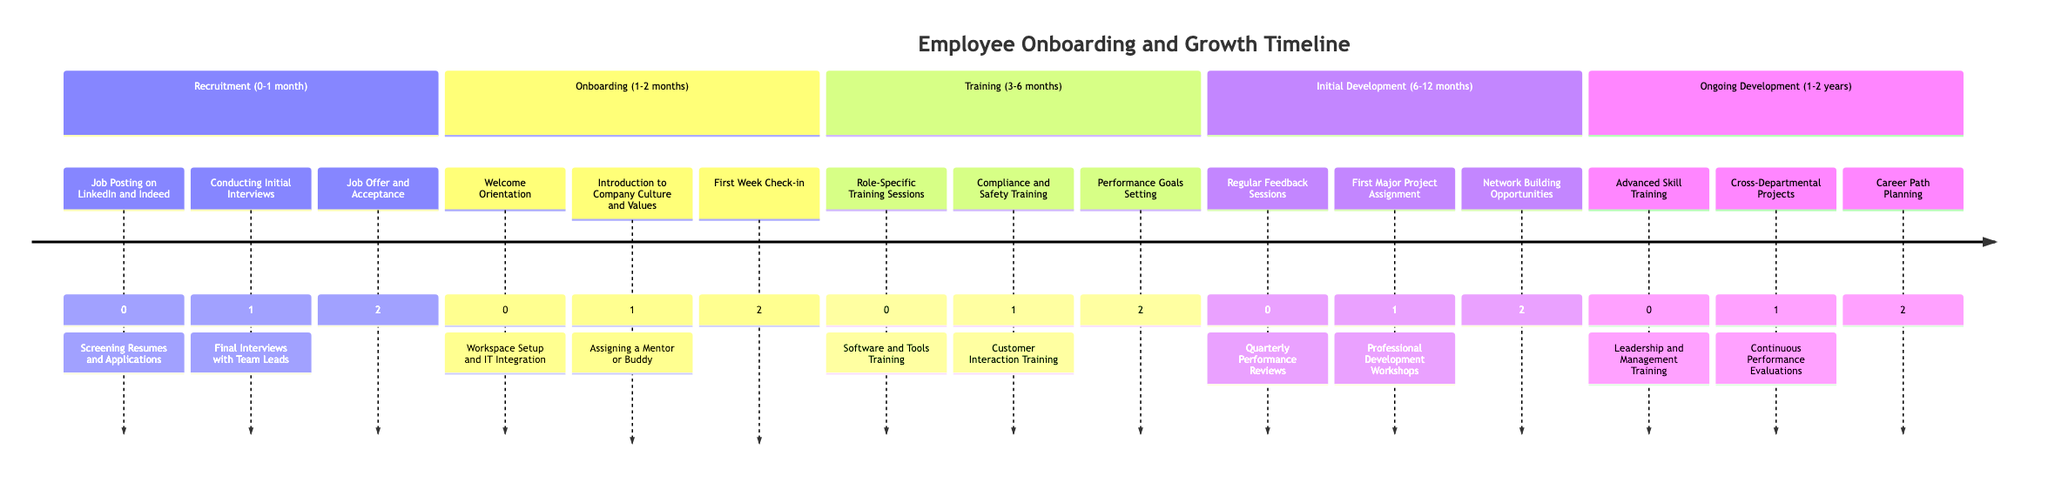What is the duration of the Onboarding phase? The Onboarding phase lasts from 1 to 2 months according to the timeline, which clearly states the range for that phase.
Answer: 1-2 months How many activities are listed for the Training phase? The Training phase includes five activities: Role-Specific Training Sessions, Software and Tools Training, Compliance and Safety Training, Customer Interaction Training, and Performance Goals Setting. Therefore, counting these gives a total of five.
Answer: 5 Which activity comes immediately after "Conducting Initial Interviews" in the Recruitment phase? Looking at the Recruitment phase, the activity "Conducting Initial Interviews" is followed immediately by "Final Interviews with Team Leads." This sequential order can be seen in the timeline.
Answer: Final Interviews with Team Leads What is the last activity listed in the Ongoing Development phase? The last activity in the Ongoing Development phase is "Career Path Planning," which is noted as the final item in that section of the timeline.
Answer: Career Path Planning What is the name of the first major project assignment in the Initial Development phase? The first major project assignment in the Initial Development phase is called "First Major Project Assignment," which is specifically mentioned as an activity.
Answer: First Major Project Assignment Which phase follows directly after Training? According to the timeline, the phase that follows directly after Training is the Initial Development phase, as the timeline progresses sequentially through these stages.
Answer: Initial Development How long is the duration of the Ongoing Development phase? The Ongoing Development phase lasts from 1 to 2 years, as clearly stated within the timeline for that particular phase.
Answer: 1-2 years What training activity is focused on leadership skills? The training activity focused on leadership skills is "Leadership and Management Training," which is explicitly mentioned in the Ongoing Development phase.
Answer: Leadership and Management Training Which phase is characterized by regular feedback sessions? The phase characterized by regular feedback sessions is the Initial Development phase, where such feedback is a outlined activity.
Answer: Initial Development 